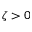<formula> <loc_0><loc_0><loc_500><loc_500>\zeta > 0</formula> 